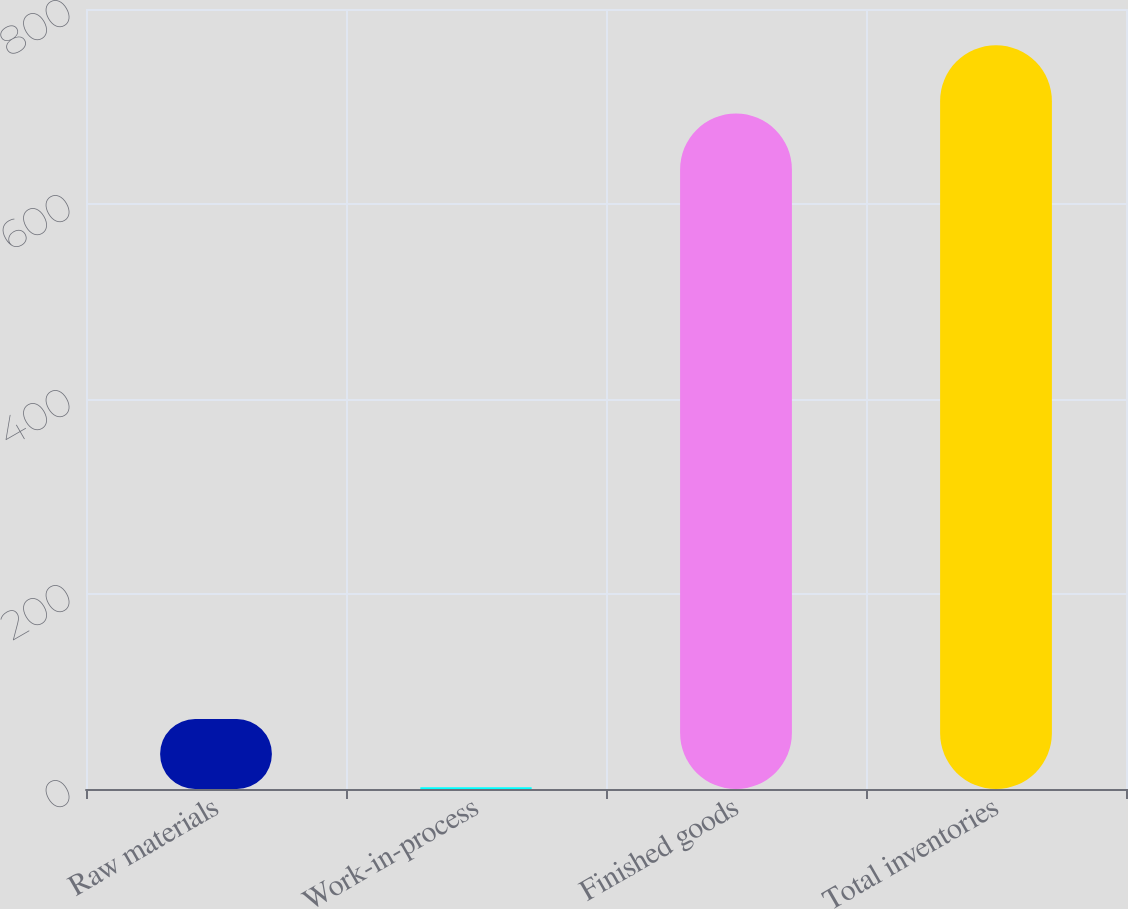Convert chart. <chart><loc_0><loc_0><loc_500><loc_500><bar_chart><fcel>Raw materials<fcel>Work-in-process<fcel>Finished goods<fcel>Total inventories<nl><fcel>71.83<fcel>1.8<fcel>692.8<fcel>762.83<nl></chart> 